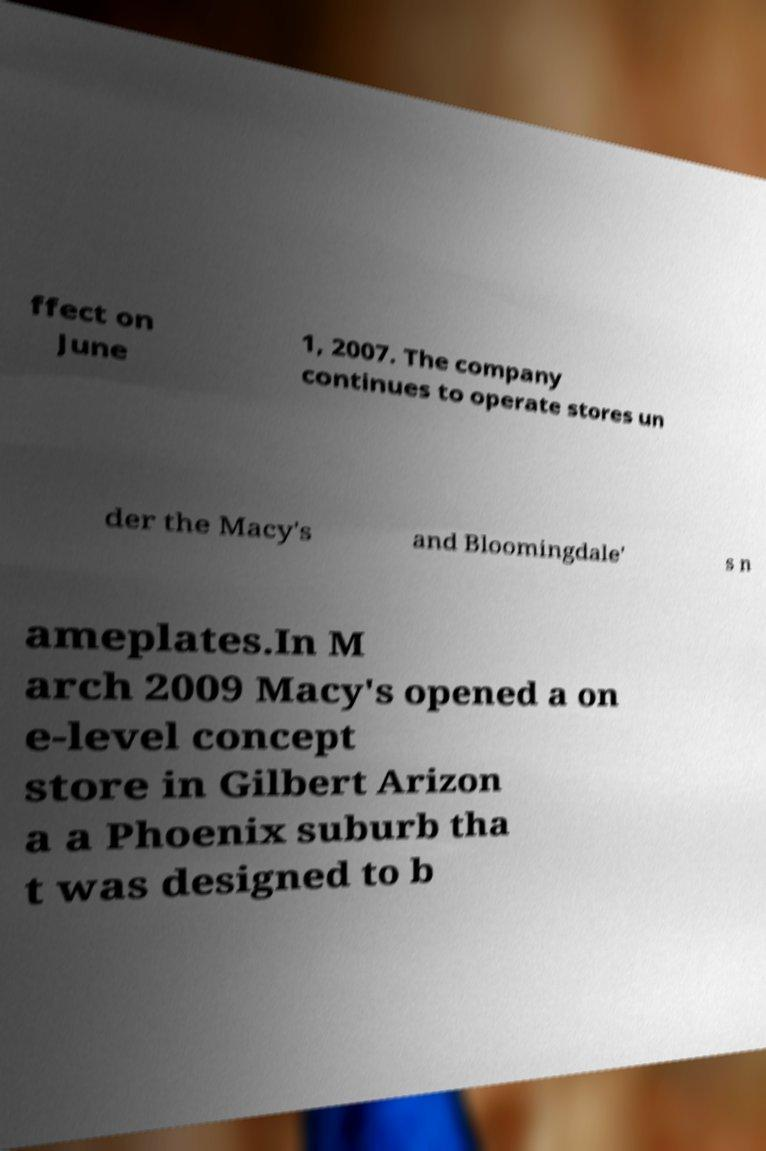Please identify and transcribe the text found in this image. ffect on June 1, 2007. The company continues to operate stores un der the Macy's and Bloomingdale' s n ameplates.In M arch 2009 Macy's opened a on e-level concept store in Gilbert Arizon a a Phoenix suburb tha t was designed to b 